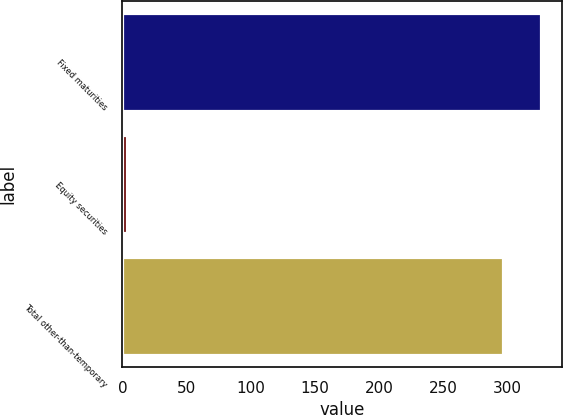<chart> <loc_0><loc_0><loc_500><loc_500><bar_chart><fcel>Fixed maturities<fcel>Equity securities<fcel>Total other-than-temporary<nl><fcel>325.93<fcel>3.7<fcel>296.3<nl></chart> 